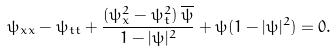<formula> <loc_0><loc_0><loc_500><loc_500>\psi _ { x x } - \psi _ { t t } + \frac { ( \psi _ { x } ^ { 2 } - \psi _ { t } ^ { 2 } ) \, \overline { \psi } } { 1 - | \psi | ^ { 2 } } + \psi ( 1 - | \psi | ^ { 2 } ) = 0 .</formula> 